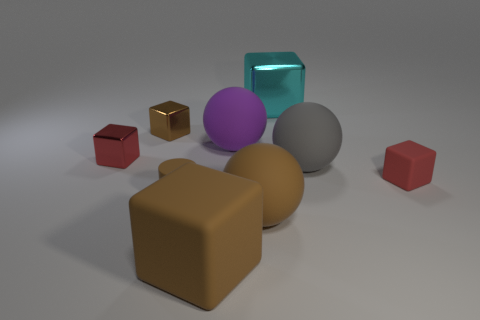Subtract all gray cubes. Subtract all purple cylinders. How many cubes are left? 5 Add 1 cyan blocks. How many objects exist? 10 Subtract all spheres. How many objects are left? 6 Subtract 1 cyan blocks. How many objects are left? 8 Subtract all small brown things. Subtract all rubber cylinders. How many objects are left? 6 Add 2 small rubber cylinders. How many small rubber cylinders are left? 3 Add 4 small red matte cubes. How many small red matte cubes exist? 5 